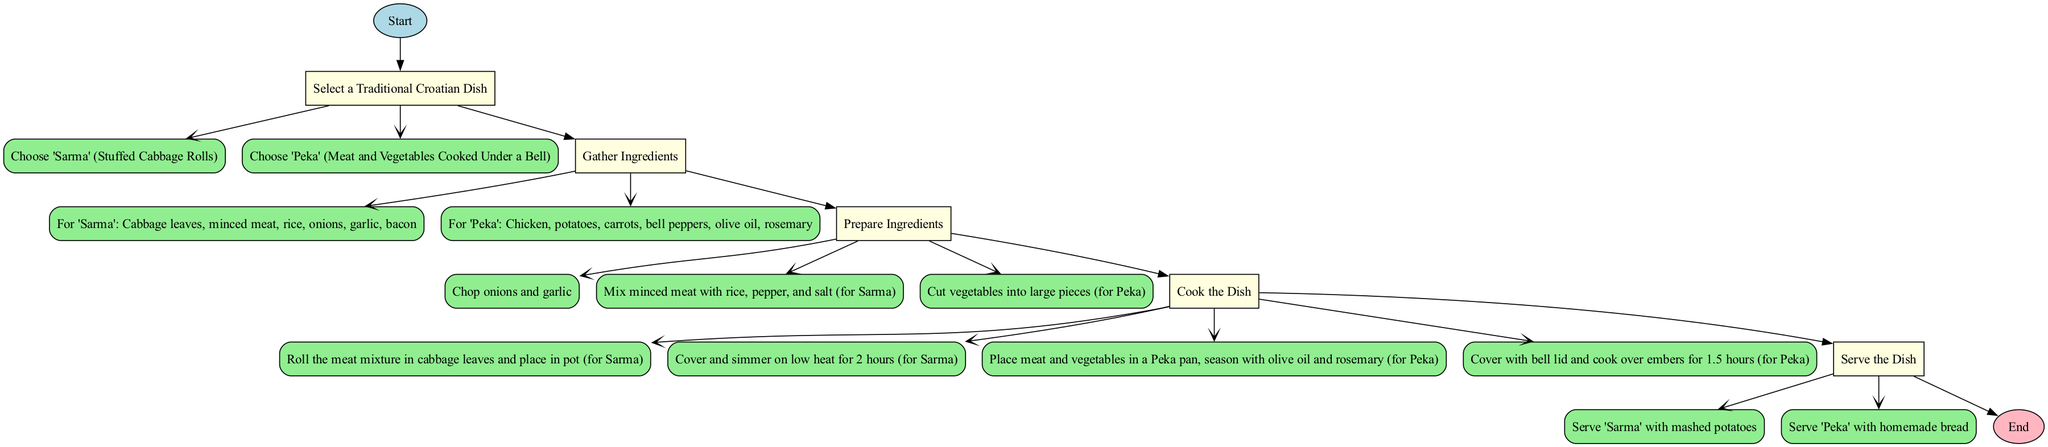What is the first step in the process? The first step in the process is indicated by the node after the 'Start' node. It is labeled as "Select a Traditional Croatian Dish".
Answer: Select a Traditional Croatian Dish How many actions follow the step "Gather Ingredients"? The "Gather Ingredients" step has two associated actions, as seen in the diagram. They describe the ingredients for 'Sarma' and 'Peka'.
Answer: 2 What dish requires cabbage leaves as an ingredient? Looking at the actions under the "Gather Ingredients" step, 'Sarma' is the dish that lists cabbage leaves as an ingredient.
Answer: Sarma What is required to prepare ingredients for 'Peka'? The preparation action for 'Peka' specifies that the vegetables need to be cut into large pieces.
Answer: Cut vegetables into large pieces How long does 'Sarma' need to simmer? The time of simmering is specified in the actions under the "Cook the Dish" step related to 'Sarma', which states that it should simmer on low heat for 2 hours.
Answer: 2 hours After cooking, what should 'Sarma' be served with? The action describing how to serve 'Sarma' indicates that it should be served with mashed potatoes.
Answer: Mashed potatoes How are the ingredients mixed for 'Sarma'? 'Sarma' preparation indicates that minced meat is mixed with rice, pepper, and salt.
Answer: Mixed with rice, pepper, and salt What is the second step in the process? The second step in the process, as identified sequentially after the 'Select a Traditional Croatian Dish', is "Gather Ingredients".
Answer: Gather Ingredients Which dish cooks over embers? The cooking method for 'Peka' specifically mentions that it is covered with a bell lid and cooked over embers.
Answer: Peka 